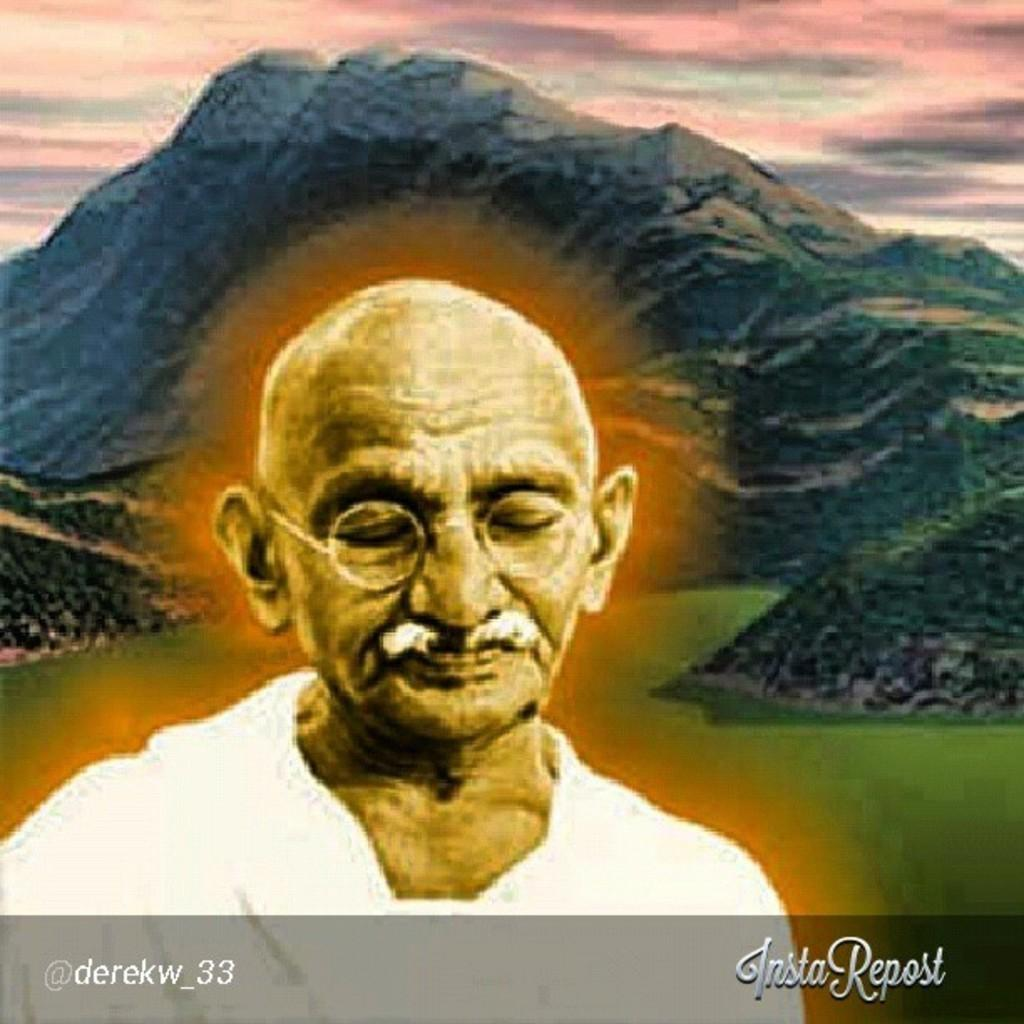What is depicted in the painting in the image? There is a painting of a man in the image. What can be seen in the distance behind the man in the painting? There are mountains in the background of the image. What type of vegetation is present on the ground in the image? There is grass on the ground in the image. What color is the kitty's stomach in the image? There is no kitty present in the image, so we cannot determine the color of its stomach. 